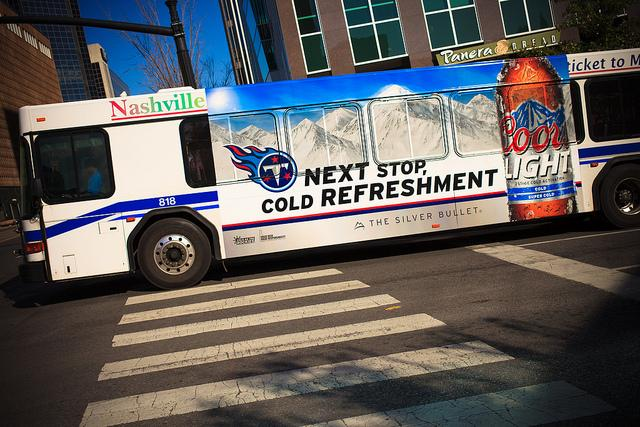Who is the road for? Please explain your reasoning. drivers. Cars drive on the road. 